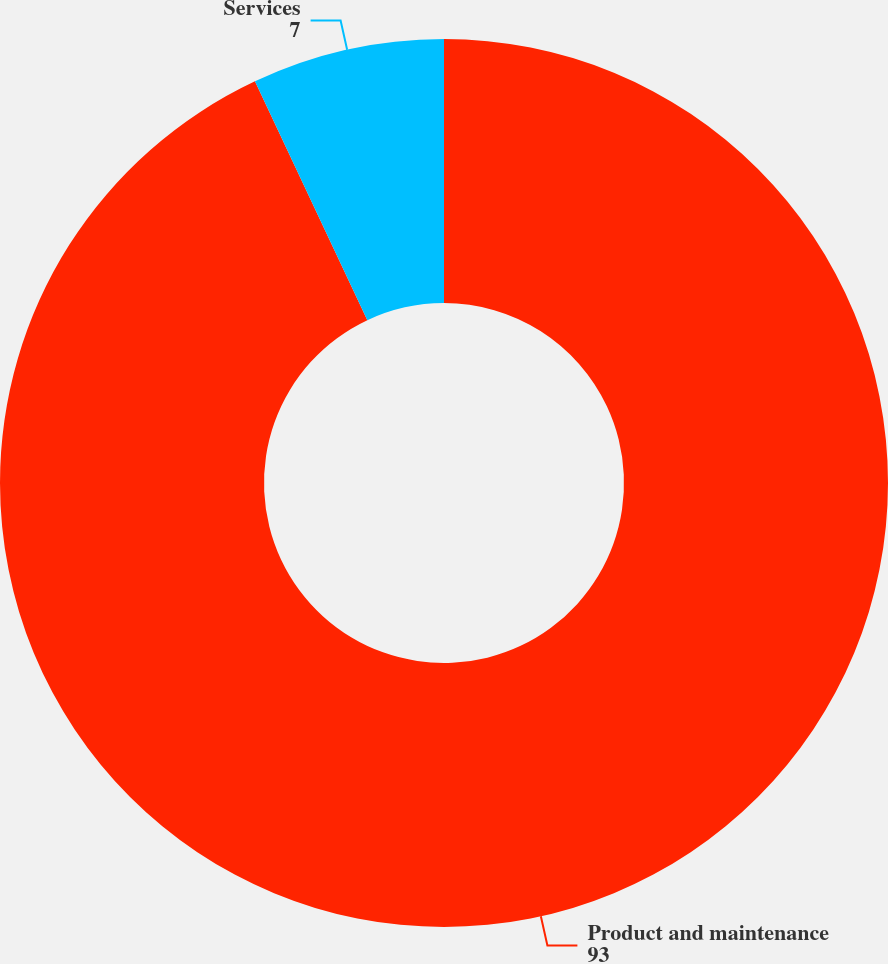<chart> <loc_0><loc_0><loc_500><loc_500><pie_chart><fcel>Product and maintenance<fcel>Services<nl><fcel>93.0%<fcel>7.0%<nl></chart> 